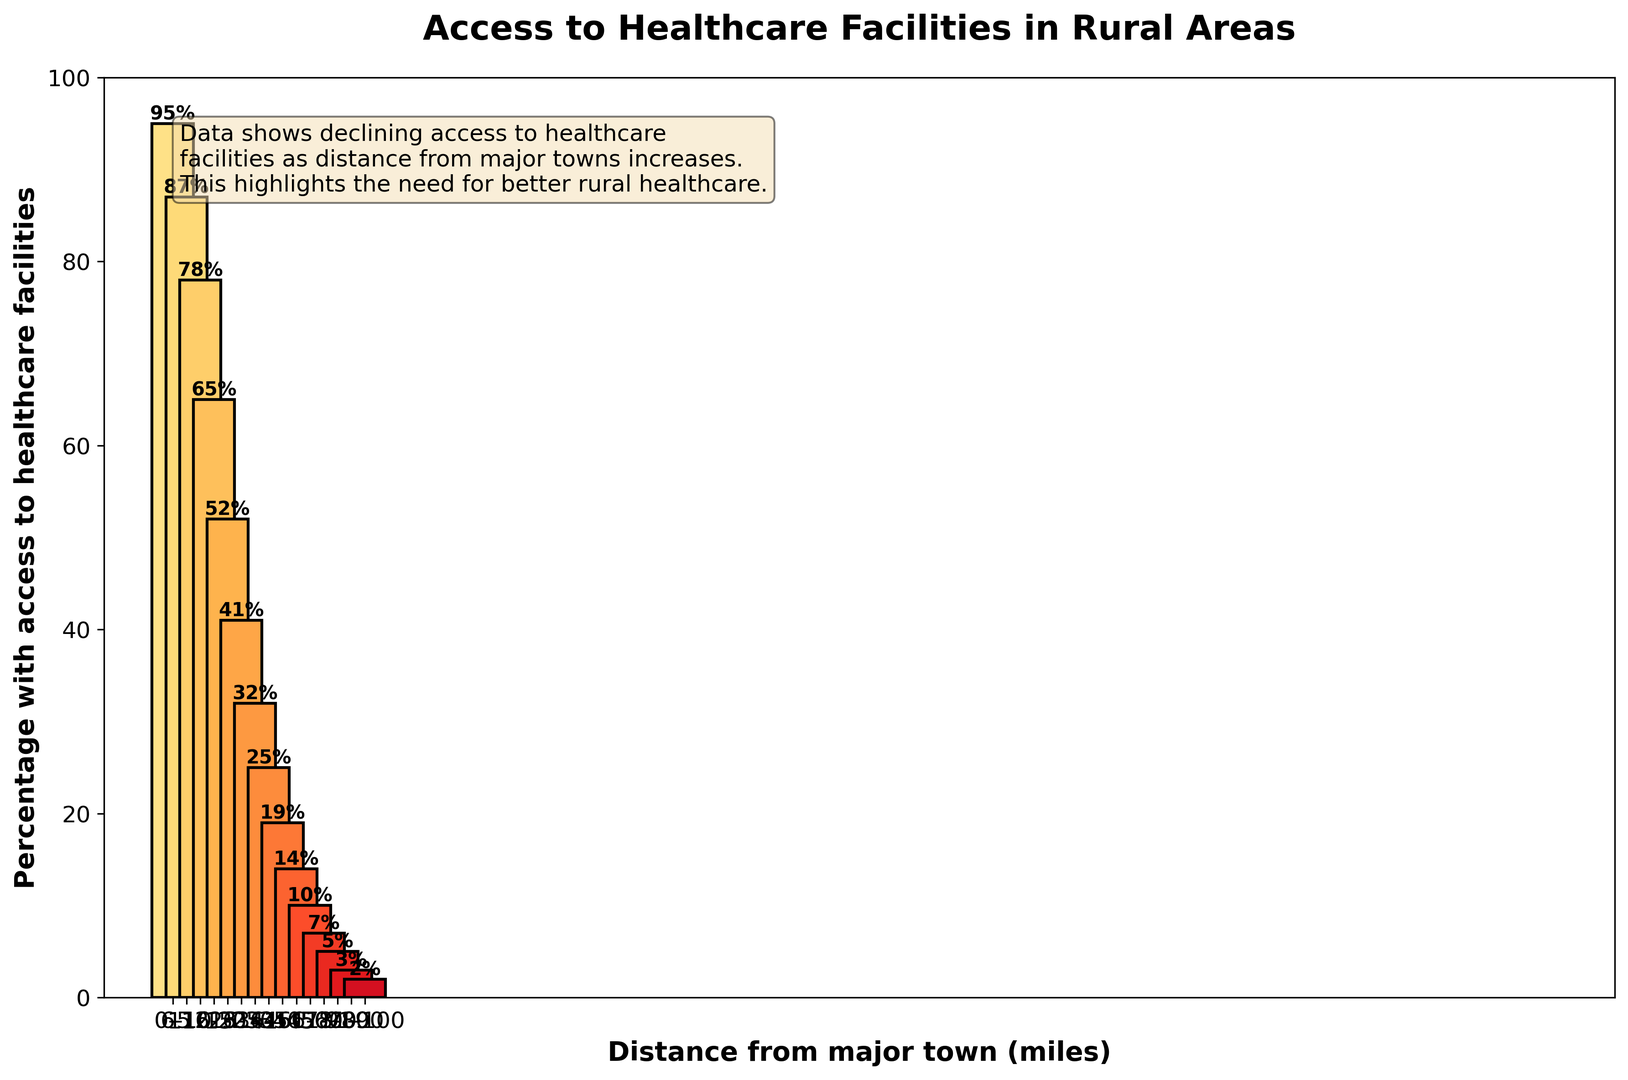How does access to healthcare facilities change as the distance from major towns increases? As the distance from major towns increases, the percentage of the rural population with access to healthcare facilities steadily decreases. This is evident from the descending bar heights in the chart.
Answer: It decreases Which distance range has the highest percentage of rural population with access to healthcare facilities? The chart shows that the distance range of 0-5 miles has the highest percentage of the rural population with access to healthcare facilities, as indicated by the tallest bar.
Answer: 0-5 miles What is the percentage difference in access to healthcare facilities between the 0-5 miles range and the 51-60 miles range? The percentage for 0-5 miles is 95%, and for 51-60 miles, it is 10%. The difference is calculated as 95% - 10% = 85%.
Answer: 85% Which distance range sees the sharpest decline in the percentage of rural population with access to healthcare facilities? Observing the height of the bars, the sharpest decline appears between the 0-5 miles (95%) and 6-10 miles (87%).
Answer: 0-5 miles and 6-10 miles How does the bar color change as the distance increases? The bars become progressively darker from left to right, indicating a transition from lighter shades of yellow to deeper shades of red.
Answer: They become darker What is the average percentage of rural population with access to healthcare for the distances 21-30 miles? The given percentages for 21-25 miles and 26-30 miles are 52% and 41%, respectively. The average is calculated as (52 + 41) / 2 = 46.5%.
Answer: 46.5% What trend does the text box in the figure summarize about access to healthcare facilities in rural areas? The text box summarizes that access to healthcare facilities declines as the distance from major towns increases, emphasizing the need for better rural healthcare.
Answer: Declining access with increased distance Between which two distance ranges is the percentage of rural population with access to healthcare facilities closest in value? The chart shows that the percentages for the distance ranges 36-40 miles and 41-45 miles are closest, being 25% and 19%, respectively, with a difference of 6%.
Answer: 36-40 miles and 41-45 miles 